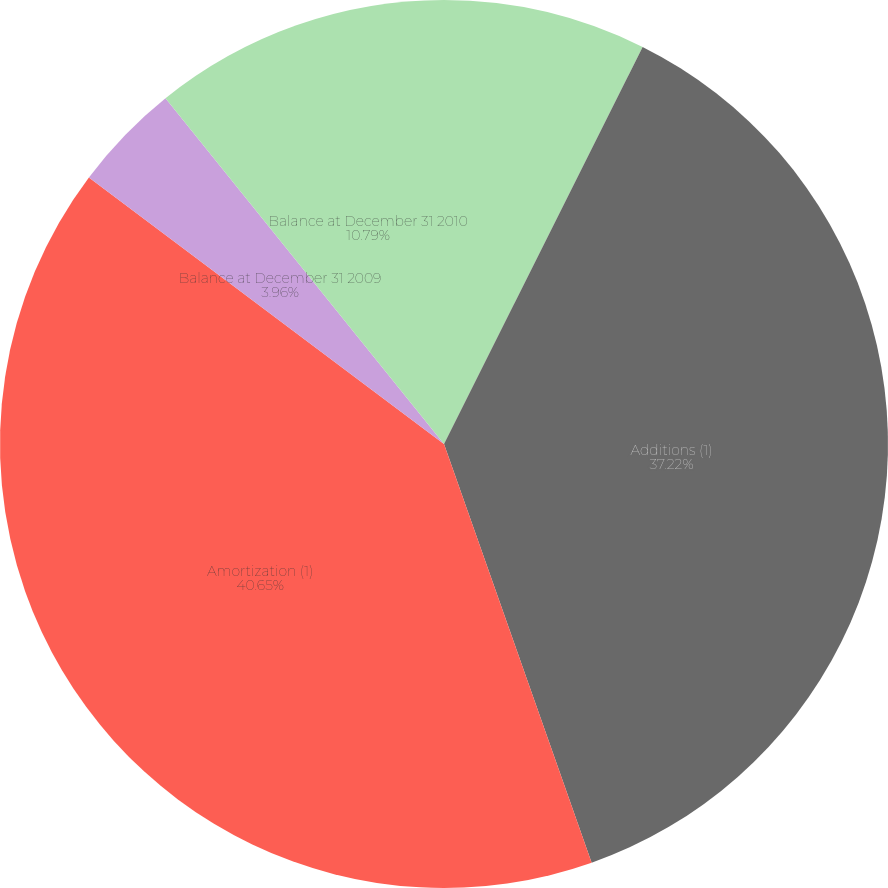<chart> <loc_0><loc_0><loc_500><loc_500><pie_chart><fcel>Balance at January 1 2009<fcel>Additions (1)<fcel>Amortization (1)<fcel>Balance at December 31 2009<fcel>Balance at December 31 2010<nl><fcel>7.38%<fcel>37.22%<fcel>40.64%<fcel>3.96%<fcel>10.79%<nl></chart> 